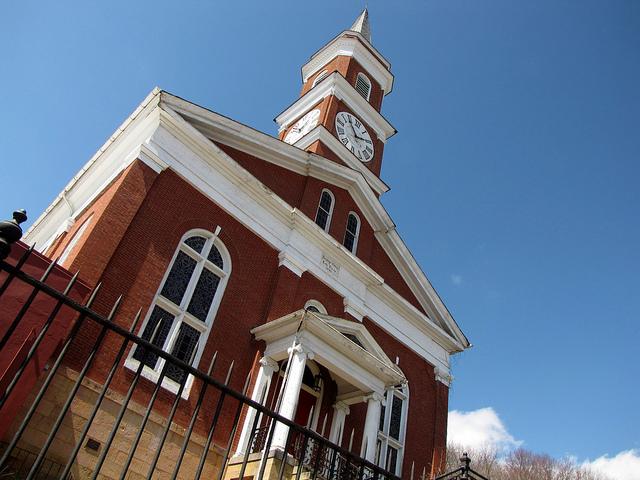What color is the building?
Keep it brief. Red. What time does the clock show?
Short answer required. 11:10. Do you see clouds?
Give a very brief answer. Yes. How many bricks are in the image?
Write a very short answer. 200. What is the color of the sky?
Write a very short answer. Blue. 